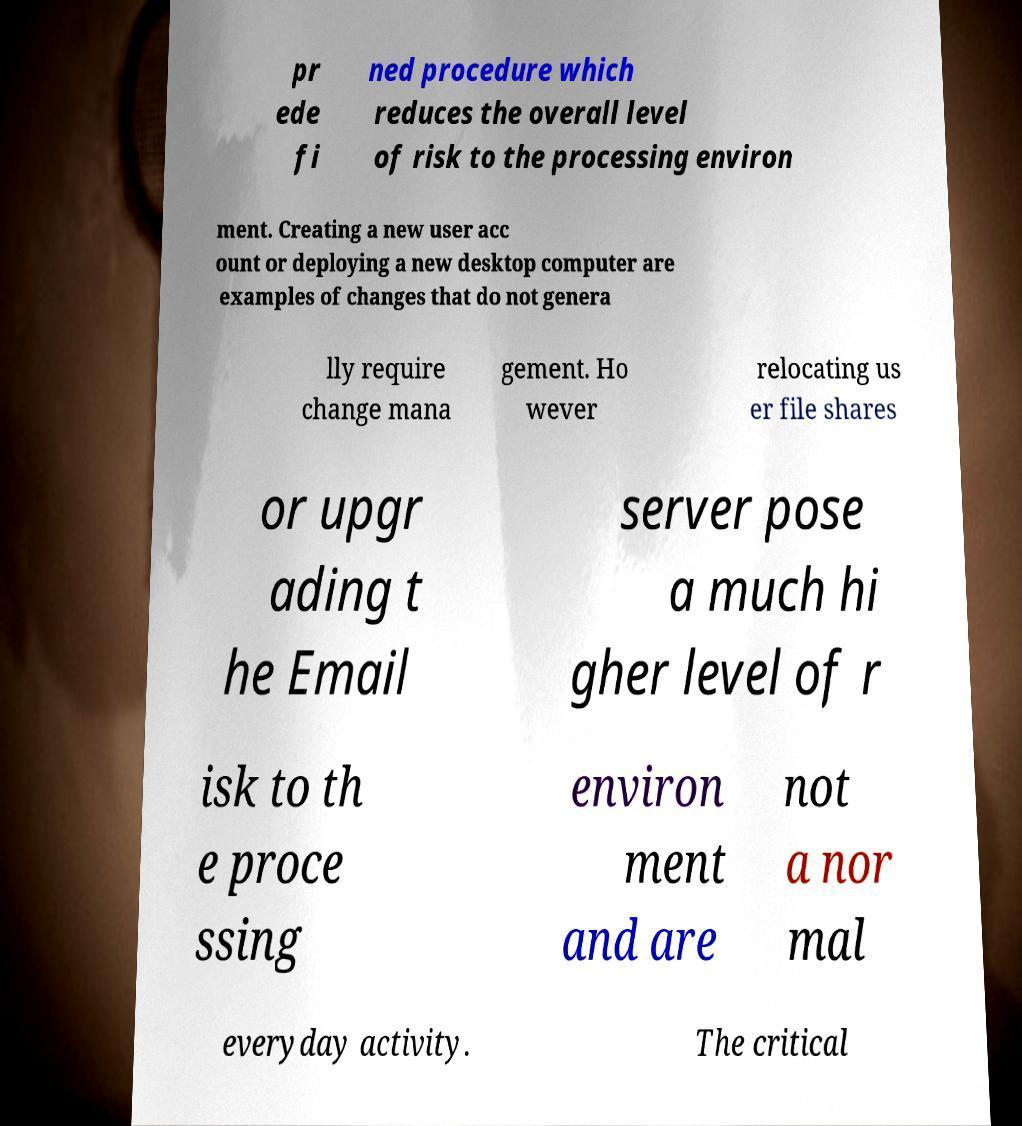Can you read and provide the text displayed in the image?This photo seems to have some interesting text. Can you extract and type it out for me? pr ede fi ned procedure which reduces the overall level of risk to the processing environ ment. Creating a new user acc ount or deploying a new desktop computer are examples of changes that do not genera lly require change mana gement. Ho wever relocating us er file shares or upgr ading t he Email server pose a much hi gher level of r isk to th e proce ssing environ ment and are not a nor mal everyday activity. The critical 